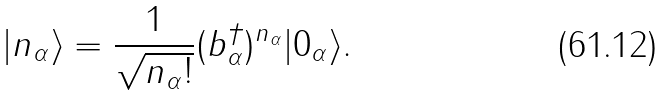<formula> <loc_0><loc_0><loc_500><loc_500>| n _ { \alpha } \rangle = { \frac { 1 } { \sqrt { n _ { \alpha } ! } } } ( b _ { \alpha } ^ { \dagger } ) ^ { n _ { \alpha } } | 0 _ { \alpha } \rangle .</formula> 